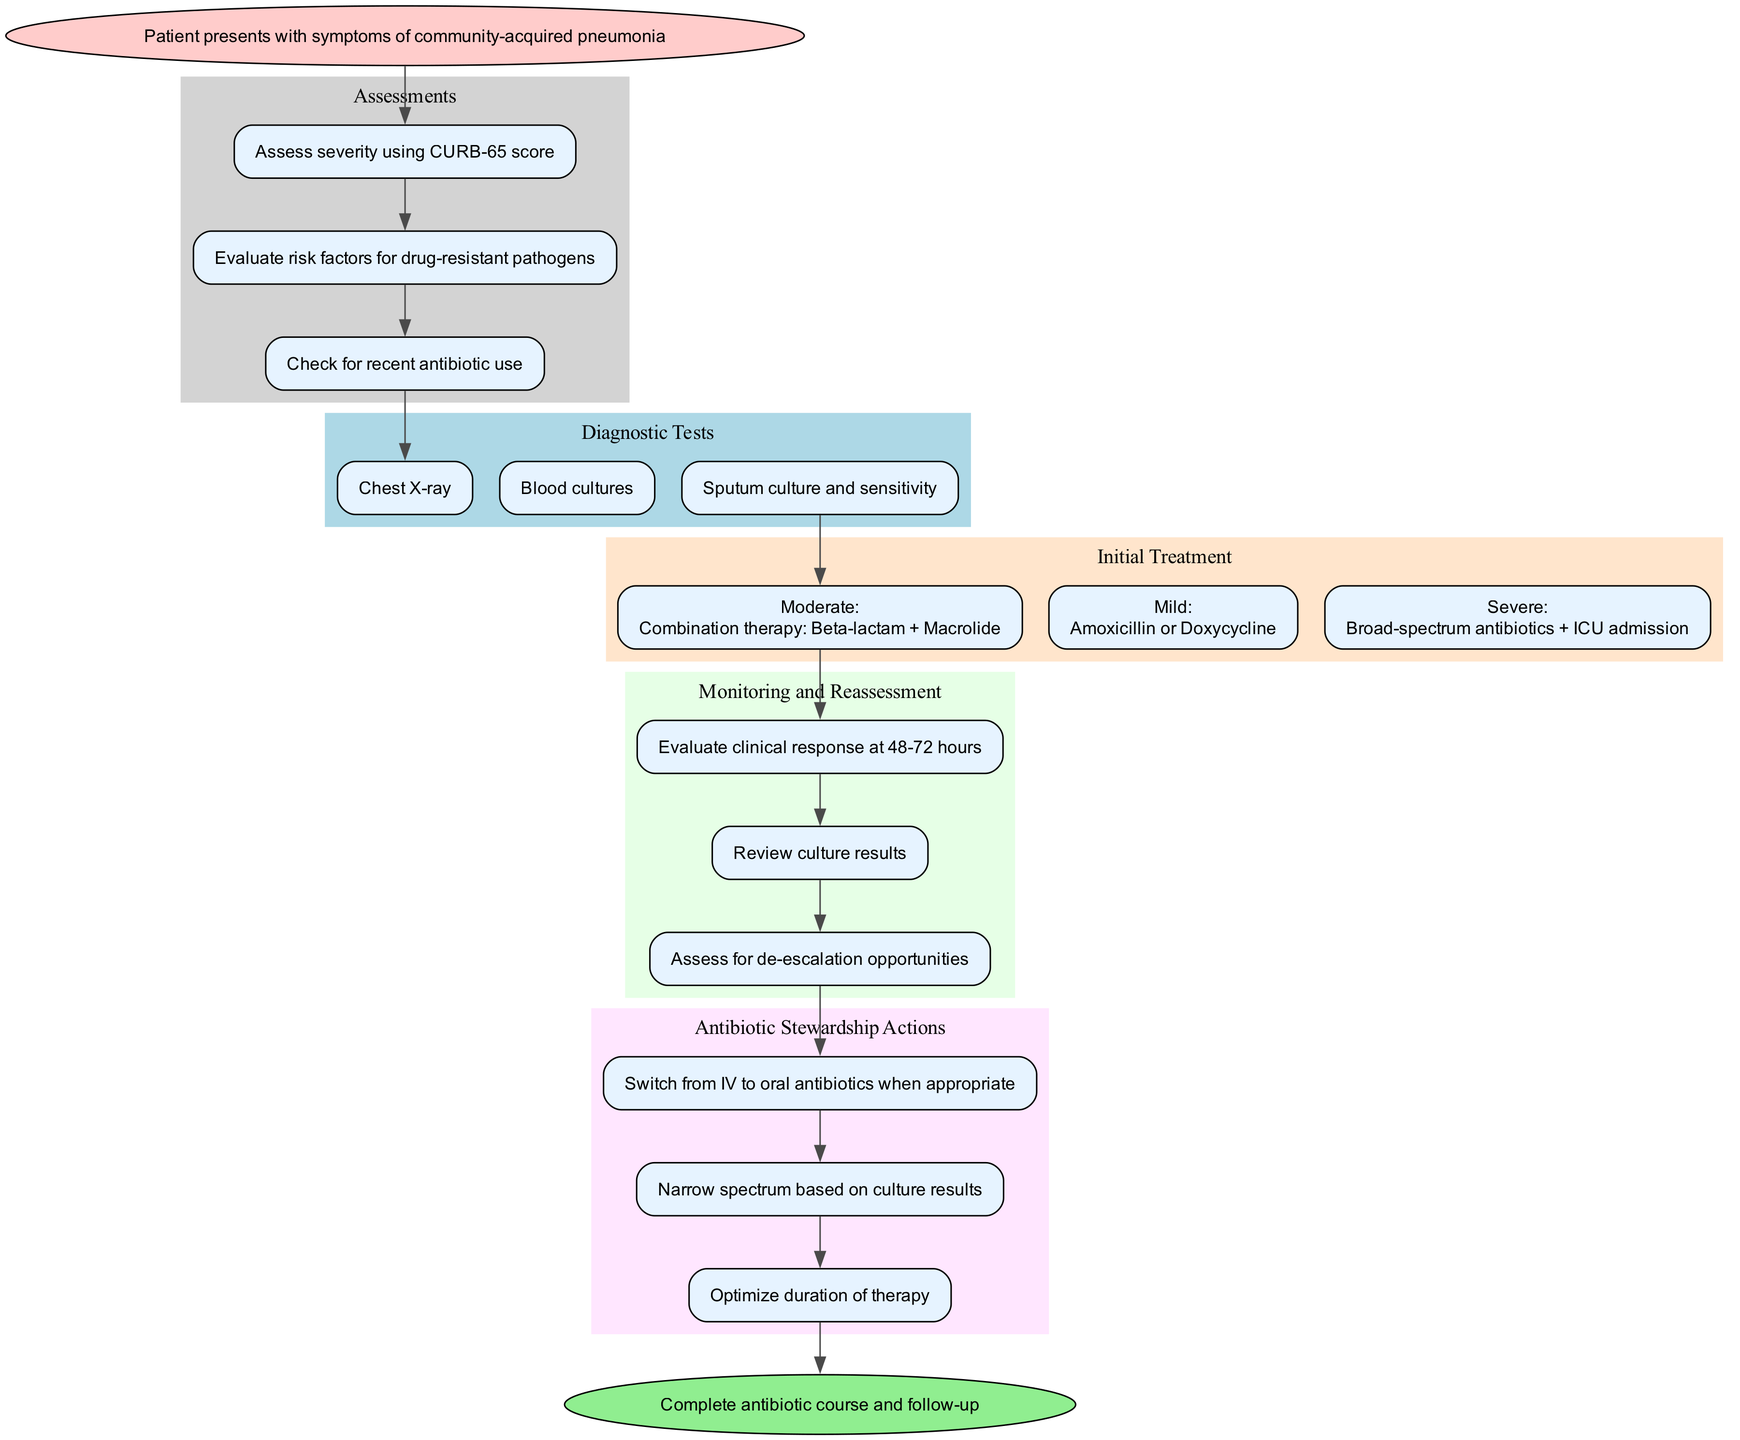What is the starting point of the clinical pathway? The starting point is explicitly labeled in the diagram as "Patient presents with symptoms of community-acquired pneumonia." This is the first node shown, and it is where the process begins.
Answer: Patient presents with symptoms of community-acquired pneumonia How many assessments are listed in the diagram? By counting the nodes within the "Assessments" cluster, we see there are three distinct assessments mentioned. This gives us the total count of assessments in the pathway.
Answer: 3 What are the mild initial treatment options for community-acquired pneumonia? The diagram specifies the treatment for mild conditions under the "Initial Treatment" section stating "Amoxicillin or Doxycycline." This information is directly taken from the relevant node.
Answer: Amoxicillin or Doxycycline What action is recommended after monitoring the patient's response? In the "Monitoring and Reassessment" section, the last step indicates to "Assess for de-escalation opportunities," which suggests the next relevant action in the pathway following the evaluation of clinical response.
Answer: Assess for de-escalation opportunities What is the endpoint of the clinical pathway? The endpoint is denoted in the diagram and clearly states "Complete antibiotic course and follow-up." This indicates the conclusion of the clinical pathway process.
Answer: Complete antibiotic course and follow-up Which diagnostic test follows the assessments in the pathway? The last assessment "Check for recent antibiotic use" leads directly to the first diagnostic test, which is a "Chest X-ray." This indicates the flow from assessments to diagnostic testing.
Answer: Chest X-ray What type of antibiotics is recommended for severe cases of pneumonia? The diagram states that for severe cases, the treatment prescribed includes "Broad-spectrum antibiotics + ICU admission." This information provides insight into the therapy for severe cases.
Answer: Broad-spectrum antibiotics + ICU admission How many antibiotic stewardship actions are proposed? There are three distinct actions listed under the "Antibiotic Stewardship Actions" section. By counting these nodes, we find the total number proposed in this stage of the pathway.
Answer: 3 